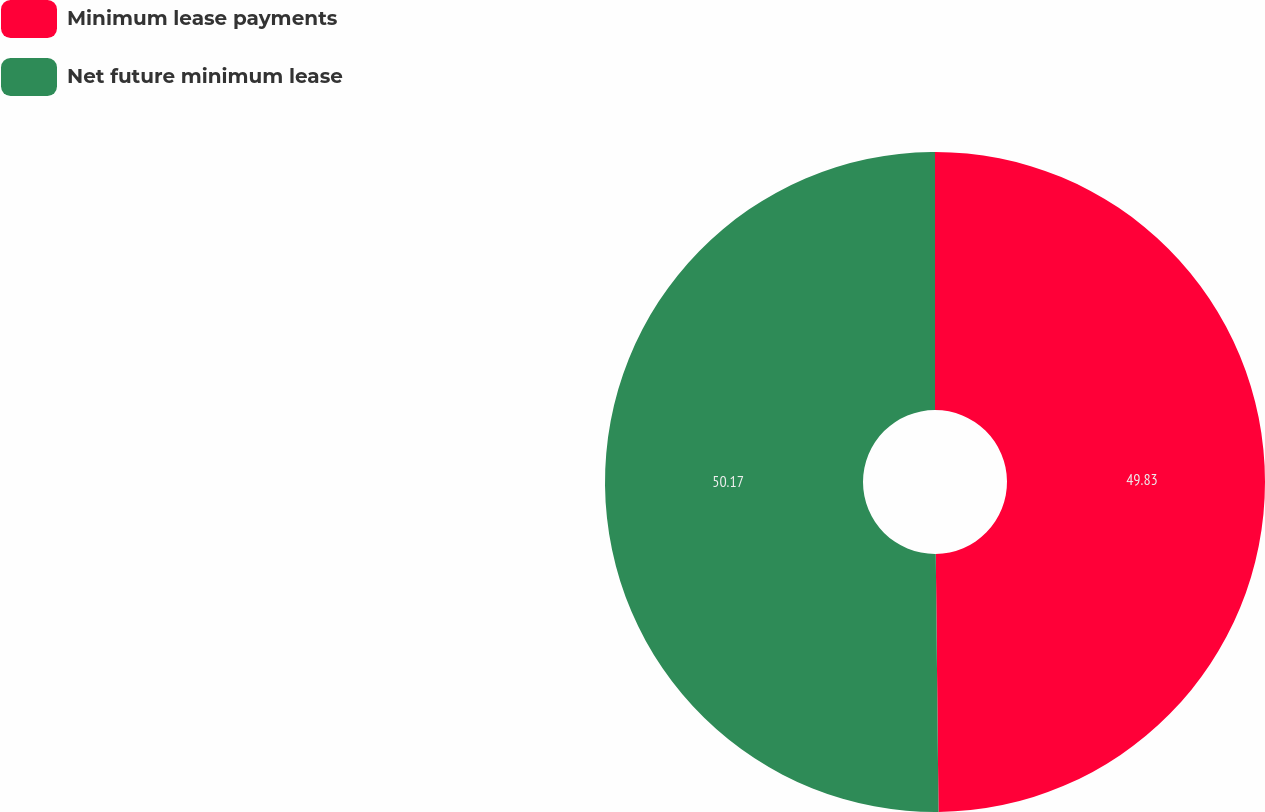Convert chart to OTSL. <chart><loc_0><loc_0><loc_500><loc_500><pie_chart><fcel>Minimum lease payments<fcel>Net future minimum lease<nl><fcel>49.83%<fcel>50.17%<nl></chart> 